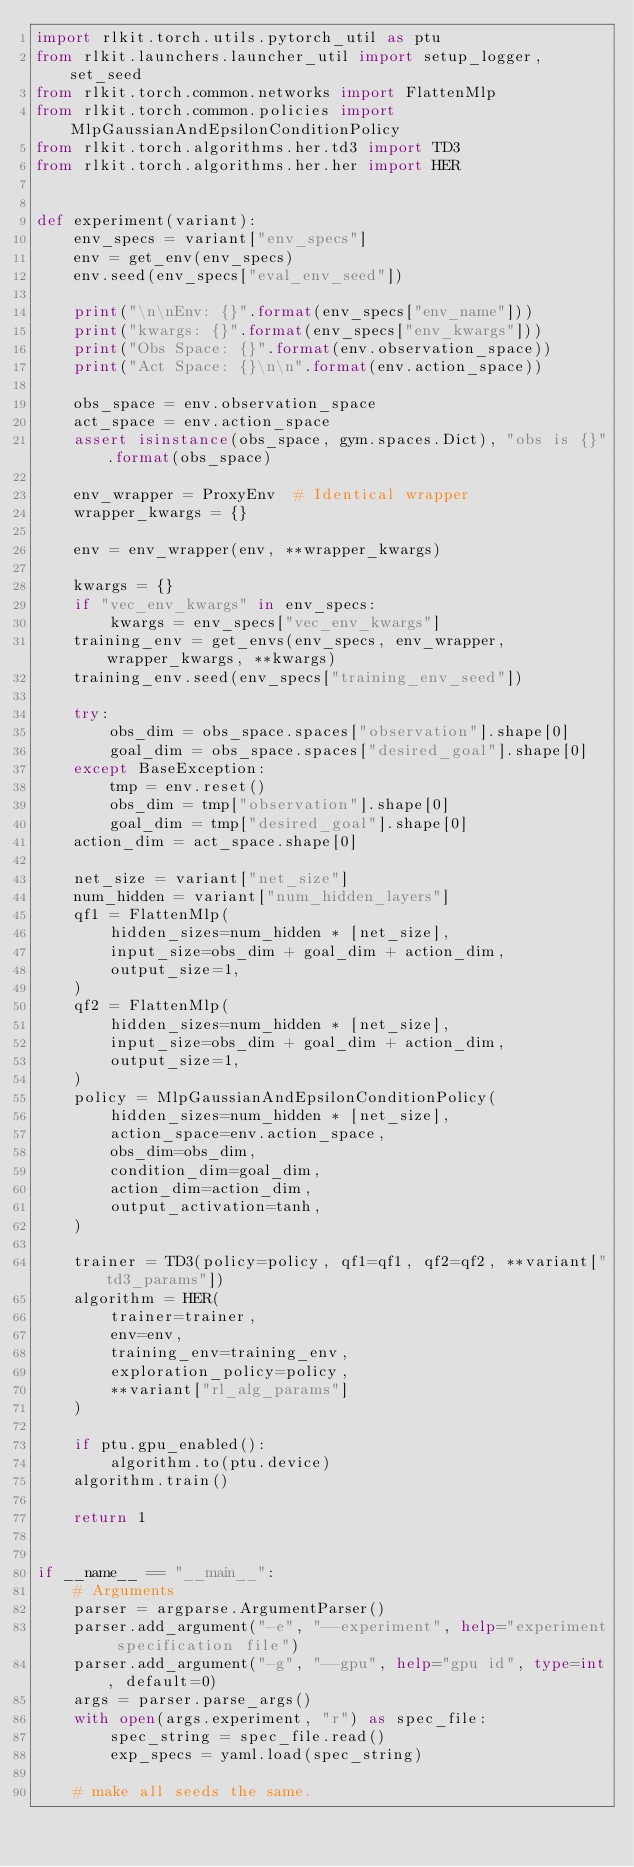Convert code to text. <code><loc_0><loc_0><loc_500><loc_500><_Python_>import rlkit.torch.utils.pytorch_util as ptu
from rlkit.launchers.launcher_util import setup_logger, set_seed
from rlkit.torch.common.networks import FlattenMlp
from rlkit.torch.common.policies import MlpGaussianAndEpsilonConditionPolicy
from rlkit.torch.algorithms.her.td3 import TD3
from rlkit.torch.algorithms.her.her import HER


def experiment(variant):
    env_specs = variant["env_specs"]
    env = get_env(env_specs)
    env.seed(env_specs["eval_env_seed"])

    print("\n\nEnv: {}".format(env_specs["env_name"]))
    print("kwargs: {}".format(env_specs["env_kwargs"]))
    print("Obs Space: {}".format(env.observation_space))
    print("Act Space: {}\n\n".format(env.action_space))

    obs_space = env.observation_space
    act_space = env.action_space
    assert isinstance(obs_space, gym.spaces.Dict), "obs is {}".format(obs_space)

    env_wrapper = ProxyEnv  # Identical wrapper
    wrapper_kwargs = {}

    env = env_wrapper(env, **wrapper_kwargs)

    kwargs = {}
    if "vec_env_kwargs" in env_specs:
        kwargs = env_specs["vec_env_kwargs"]
    training_env = get_envs(env_specs, env_wrapper, wrapper_kwargs, **kwargs)
    training_env.seed(env_specs["training_env_seed"])

    try:
        obs_dim = obs_space.spaces["observation"].shape[0]
        goal_dim = obs_space.spaces["desired_goal"].shape[0]
    except BaseException:
        tmp = env.reset()
        obs_dim = tmp["observation"].shape[0]
        goal_dim = tmp["desired_goal"].shape[0]
    action_dim = act_space.shape[0]

    net_size = variant["net_size"]
    num_hidden = variant["num_hidden_layers"]
    qf1 = FlattenMlp(
        hidden_sizes=num_hidden * [net_size],
        input_size=obs_dim + goal_dim + action_dim,
        output_size=1,
    )
    qf2 = FlattenMlp(
        hidden_sizes=num_hidden * [net_size],
        input_size=obs_dim + goal_dim + action_dim,
        output_size=1,
    )
    policy = MlpGaussianAndEpsilonConditionPolicy(
        hidden_sizes=num_hidden * [net_size],
        action_space=env.action_space,
        obs_dim=obs_dim,
        condition_dim=goal_dim,
        action_dim=action_dim,
        output_activation=tanh,
    )

    trainer = TD3(policy=policy, qf1=qf1, qf2=qf2, **variant["td3_params"])
    algorithm = HER(
        trainer=trainer,
        env=env,
        training_env=training_env,
        exploration_policy=policy,
        **variant["rl_alg_params"]
    )

    if ptu.gpu_enabled():
        algorithm.to(ptu.device)
    algorithm.train()

    return 1


if __name__ == "__main__":
    # Arguments
    parser = argparse.ArgumentParser()
    parser.add_argument("-e", "--experiment", help="experiment specification file")
    parser.add_argument("-g", "--gpu", help="gpu id", type=int, default=0)
    args = parser.parse_args()
    with open(args.experiment, "r") as spec_file:
        spec_string = spec_file.read()
        exp_specs = yaml.load(spec_string)

    # make all seeds the same.</code> 